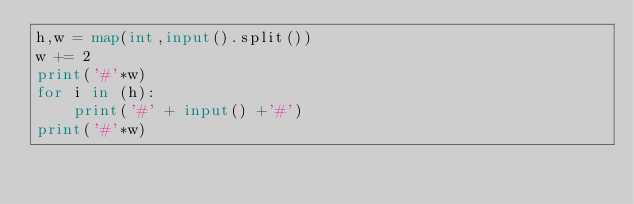<code> <loc_0><loc_0><loc_500><loc_500><_Python_>h,w = map(int,input().split())
w += 2
print('#'*w)
for i in (h):
    print('#' + input() +'#')
print('#'*w)</code> 